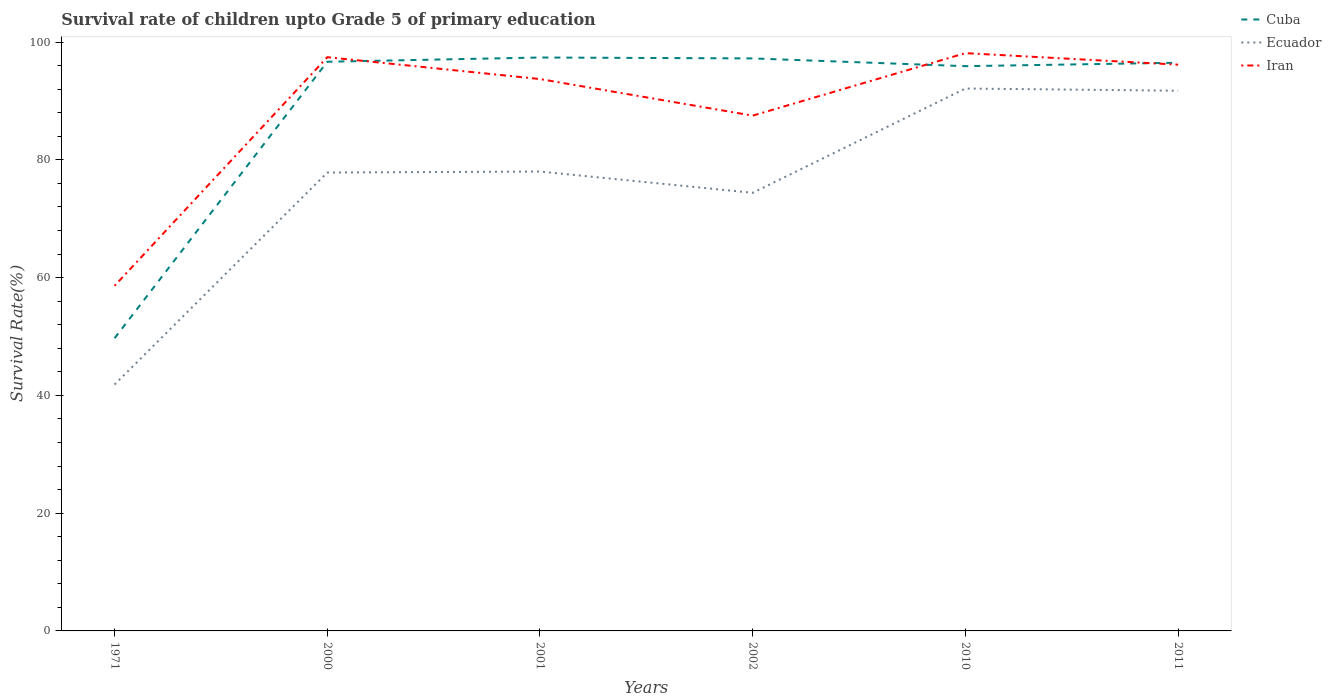How many different coloured lines are there?
Offer a terse response. 3. Across all years, what is the maximum survival rate of children in Iran?
Offer a very short reply. 58.61. What is the total survival rate of children in Ecuador in the graph?
Provide a succinct answer. -36. What is the difference between the highest and the second highest survival rate of children in Ecuador?
Make the answer very short. 50.27. Is the survival rate of children in Ecuador strictly greater than the survival rate of children in Iran over the years?
Offer a very short reply. Yes. How many lines are there?
Your answer should be very brief. 3. How many years are there in the graph?
Make the answer very short. 6. Are the values on the major ticks of Y-axis written in scientific E-notation?
Offer a very short reply. No. Does the graph contain any zero values?
Offer a very short reply. No. How many legend labels are there?
Provide a short and direct response. 3. What is the title of the graph?
Your answer should be compact. Survival rate of children upto Grade 5 of primary education. What is the label or title of the Y-axis?
Provide a succinct answer. Survival Rate(%). What is the Survival Rate(%) of Cuba in 1971?
Keep it short and to the point. 49.71. What is the Survival Rate(%) in Ecuador in 1971?
Make the answer very short. 41.85. What is the Survival Rate(%) in Iran in 1971?
Ensure brevity in your answer.  58.61. What is the Survival Rate(%) in Cuba in 2000?
Offer a terse response. 96.67. What is the Survival Rate(%) in Ecuador in 2000?
Give a very brief answer. 77.85. What is the Survival Rate(%) in Iran in 2000?
Ensure brevity in your answer.  97.44. What is the Survival Rate(%) in Cuba in 2001?
Ensure brevity in your answer.  97.39. What is the Survival Rate(%) of Ecuador in 2001?
Your response must be concise. 78.02. What is the Survival Rate(%) in Iran in 2001?
Provide a short and direct response. 93.73. What is the Survival Rate(%) of Cuba in 2002?
Offer a very short reply. 97.24. What is the Survival Rate(%) in Ecuador in 2002?
Provide a short and direct response. 74.41. What is the Survival Rate(%) in Iran in 2002?
Give a very brief answer. 87.52. What is the Survival Rate(%) of Cuba in 2010?
Your answer should be very brief. 95.92. What is the Survival Rate(%) of Ecuador in 2010?
Keep it short and to the point. 92.12. What is the Survival Rate(%) of Iran in 2010?
Your answer should be very brief. 98.13. What is the Survival Rate(%) of Cuba in 2011?
Keep it short and to the point. 96.5. What is the Survival Rate(%) in Ecuador in 2011?
Your answer should be compact. 91.75. What is the Survival Rate(%) of Iran in 2011?
Your answer should be compact. 96.18. Across all years, what is the maximum Survival Rate(%) of Cuba?
Your answer should be compact. 97.39. Across all years, what is the maximum Survival Rate(%) of Ecuador?
Make the answer very short. 92.12. Across all years, what is the maximum Survival Rate(%) in Iran?
Provide a succinct answer. 98.13. Across all years, what is the minimum Survival Rate(%) in Cuba?
Provide a succinct answer. 49.71. Across all years, what is the minimum Survival Rate(%) of Ecuador?
Your response must be concise. 41.85. Across all years, what is the minimum Survival Rate(%) of Iran?
Make the answer very short. 58.61. What is the total Survival Rate(%) in Cuba in the graph?
Offer a very short reply. 533.43. What is the total Survival Rate(%) of Ecuador in the graph?
Give a very brief answer. 456. What is the total Survival Rate(%) in Iran in the graph?
Offer a very short reply. 531.61. What is the difference between the Survival Rate(%) in Cuba in 1971 and that in 2000?
Provide a succinct answer. -46.96. What is the difference between the Survival Rate(%) of Ecuador in 1971 and that in 2000?
Your answer should be compact. -36. What is the difference between the Survival Rate(%) in Iran in 1971 and that in 2000?
Your answer should be compact. -38.83. What is the difference between the Survival Rate(%) of Cuba in 1971 and that in 2001?
Offer a very short reply. -47.68. What is the difference between the Survival Rate(%) of Ecuador in 1971 and that in 2001?
Make the answer very short. -36.17. What is the difference between the Survival Rate(%) of Iran in 1971 and that in 2001?
Offer a very short reply. -35.12. What is the difference between the Survival Rate(%) in Cuba in 1971 and that in 2002?
Provide a succinct answer. -47.52. What is the difference between the Survival Rate(%) in Ecuador in 1971 and that in 2002?
Ensure brevity in your answer.  -32.56. What is the difference between the Survival Rate(%) of Iran in 1971 and that in 2002?
Make the answer very short. -28.9. What is the difference between the Survival Rate(%) in Cuba in 1971 and that in 2010?
Ensure brevity in your answer.  -46.21. What is the difference between the Survival Rate(%) of Ecuador in 1971 and that in 2010?
Your response must be concise. -50.27. What is the difference between the Survival Rate(%) in Iran in 1971 and that in 2010?
Your response must be concise. -39.52. What is the difference between the Survival Rate(%) of Cuba in 1971 and that in 2011?
Make the answer very short. -46.79. What is the difference between the Survival Rate(%) of Ecuador in 1971 and that in 2011?
Ensure brevity in your answer.  -49.9. What is the difference between the Survival Rate(%) in Iran in 1971 and that in 2011?
Offer a very short reply. -37.56. What is the difference between the Survival Rate(%) of Cuba in 2000 and that in 2001?
Offer a very short reply. -0.72. What is the difference between the Survival Rate(%) in Ecuador in 2000 and that in 2001?
Give a very brief answer. -0.17. What is the difference between the Survival Rate(%) of Iran in 2000 and that in 2001?
Keep it short and to the point. 3.71. What is the difference between the Survival Rate(%) in Cuba in 2000 and that in 2002?
Offer a terse response. -0.57. What is the difference between the Survival Rate(%) of Ecuador in 2000 and that in 2002?
Your answer should be compact. 3.44. What is the difference between the Survival Rate(%) of Iran in 2000 and that in 2002?
Ensure brevity in your answer.  9.93. What is the difference between the Survival Rate(%) of Cuba in 2000 and that in 2010?
Make the answer very short. 0.75. What is the difference between the Survival Rate(%) in Ecuador in 2000 and that in 2010?
Keep it short and to the point. -14.27. What is the difference between the Survival Rate(%) of Iran in 2000 and that in 2010?
Ensure brevity in your answer.  -0.69. What is the difference between the Survival Rate(%) in Cuba in 2000 and that in 2011?
Your answer should be very brief. 0.17. What is the difference between the Survival Rate(%) of Ecuador in 2000 and that in 2011?
Provide a short and direct response. -13.9. What is the difference between the Survival Rate(%) in Iran in 2000 and that in 2011?
Offer a very short reply. 1.27. What is the difference between the Survival Rate(%) in Cuba in 2001 and that in 2002?
Keep it short and to the point. 0.15. What is the difference between the Survival Rate(%) in Ecuador in 2001 and that in 2002?
Your response must be concise. 3.61. What is the difference between the Survival Rate(%) in Iran in 2001 and that in 2002?
Offer a terse response. 6.21. What is the difference between the Survival Rate(%) in Cuba in 2001 and that in 2010?
Offer a very short reply. 1.47. What is the difference between the Survival Rate(%) in Ecuador in 2001 and that in 2010?
Your response must be concise. -14.1. What is the difference between the Survival Rate(%) in Iran in 2001 and that in 2010?
Offer a very short reply. -4.4. What is the difference between the Survival Rate(%) in Cuba in 2001 and that in 2011?
Offer a terse response. 0.89. What is the difference between the Survival Rate(%) in Ecuador in 2001 and that in 2011?
Offer a terse response. -13.73. What is the difference between the Survival Rate(%) in Iran in 2001 and that in 2011?
Your answer should be very brief. -2.45. What is the difference between the Survival Rate(%) of Cuba in 2002 and that in 2010?
Give a very brief answer. 1.32. What is the difference between the Survival Rate(%) in Ecuador in 2002 and that in 2010?
Your answer should be compact. -17.71. What is the difference between the Survival Rate(%) of Iran in 2002 and that in 2010?
Give a very brief answer. -10.61. What is the difference between the Survival Rate(%) of Cuba in 2002 and that in 2011?
Make the answer very short. 0.74. What is the difference between the Survival Rate(%) in Ecuador in 2002 and that in 2011?
Provide a short and direct response. -17.34. What is the difference between the Survival Rate(%) of Iran in 2002 and that in 2011?
Provide a short and direct response. -8.66. What is the difference between the Survival Rate(%) of Cuba in 2010 and that in 2011?
Your answer should be compact. -0.58. What is the difference between the Survival Rate(%) in Ecuador in 2010 and that in 2011?
Give a very brief answer. 0.37. What is the difference between the Survival Rate(%) in Iran in 2010 and that in 2011?
Keep it short and to the point. 1.95. What is the difference between the Survival Rate(%) of Cuba in 1971 and the Survival Rate(%) of Ecuador in 2000?
Your response must be concise. -28.14. What is the difference between the Survival Rate(%) of Cuba in 1971 and the Survival Rate(%) of Iran in 2000?
Provide a short and direct response. -47.73. What is the difference between the Survival Rate(%) of Ecuador in 1971 and the Survival Rate(%) of Iran in 2000?
Provide a succinct answer. -55.6. What is the difference between the Survival Rate(%) of Cuba in 1971 and the Survival Rate(%) of Ecuador in 2001?
Offer a terse response. -28.31. What is the difference between the Survival Rate(%) in Cuba in 1971 and the Survival Rate(%) in Iran in 2001?
Keep it short and to the point. -44.02. What is the difference between the Survival Rate(%) of Ecuador in 1971 and the Survival Rate(%) of Iran in 2001?
Your answer should be compact. -51.88. What is the difference between the Survival Rate(%) in Cuba in 1971 and the Survival Rate(%) in Ecuador in 2002?
Provide a succinct answer. -24.7. What is the difference between the Survival Rate(%) in Cuba in 1971 and the Survival Rate(%) in Iran in 2002?
Keep it short and to the point. -37.8. What is the difference between the Survival Rate(%) in Ecuador in 1971 and the Survival Rate(%) in Iran in 2002?
Offer a very short reply. -45.67. What is the difference between the Survival Rate(%) in Cuba in 1971 and the Survival Rate(%) in Ecuador in 2010?
Your answer should be compact. -42.41. What is the difference between the Survival Rate(%) in Cuba in 1971 and the Survival Rate(%) in Iran in 2010?
Make the answer very short. -48.42. What is the difference between the Survival Rate(%) of Ecuador in 1971 and the Survival Rate(%) of Iran in 2010?
Offer a terse response. -56.28. What is the difference between the Survival Rate(%) in Cuba in 1971 and the Survival Rate(%) in Ecuador in 2011?
Offer a very short reply. -42.04. What is the difference between the Survival Rate(%) in Cuba in 1971 and the Survival Rate(%) in Iran in 2011?
Keep it short and to the point. -46.46. What is the difference between the Survival Rate(%) in Ecuador in 1971 and the Survival Rate(%) in Iran in 2011?
Provide a succinct answer. -54.33. What is the difference between the Survival Rate(%) of Cuba in 2000 and the Survival Rate(%) of Ecuador in 2001?
Provide a short and direct response. 18.65. What is the difference between the Survival Rate(%) of Cuba in 2000 and the Survival Rate(%) of Iran in 2001?
Ensure brevity in your answer.  2.94. What is the difference between the Survival Rate(%) of Ecuador in 2000 and the Survival Rate(%) of Iran in 2001?
Give a very brief answer. -15.88. What is the difference between the Survival Rate(%) of Cuba in 2000 and the Survival Rate(%) of Ecuador in 2002?
Offer a very short reply. 22.26. What is the difference between the Survival Rate(%) in Cuba in 2000 and the Survival Rate(%) in Iran in 2002?
Offer a terse response. 9.15. What is the difference between the Survival Rate(%) of Ecuador in 2000 and the Survival Rate(%) of Iran in 2002?
Your answer should be compact. -9.67. What is the difference between the Survival Rate(%) of Cuba in 2000 and the Survival Rate(%) of Ecuador in 2010?
Give a very brief answer. 4.55. What is the difference between the Survival Rate(%) in Cuba in 2000 and the Survival Rate(%) in Iran in 2010?
Your response must be concise. -1.46. What is the difference between the Survival Rate(%) in Ecuador in 2000 and the Survival Rate(%) in Iran in 2010?
Your answer should be very brief. -20.28. What is the difference between the Survival Rate(%) in Cuba in 2000 and the Survival Rate(%) in Ecuador in 2011?
Give a very brief answer. 4.92. What is the difference between the Survival Rate(%) of Cuba in 2000 and the Survival Rate(%) of Iran in 2011?
Offer a very short reply. 0.49. What is the difference between the Survival Rate(%) in Ecuador in 2000 and the Survival Rate(%) in Iran in 2011?
Your answer should be very brief. -18.33. What is the difference between the Survival Rate(%) in Cuba in 2001 and the Survival Rate(%) in Ecuador in 2002?
Your answer should be very brief. 22.98. What is the difference between the Survival Rate(%) of Cuba in 2001 and the Survival Rate(%) of Iran in 2002?
Your answer should be compact. 9.87. What is the difference between the Survival Rate(%) in Ecuador in 2001 and the Survival Rate(%) in Iran in 2002?
Offer a terse response. -9.49. What is the difference between the Survival Rate(%) in Cuba in 2001 and the Survival Rate(%) in Ecuador in 2010?
Ensure brevity in your answer.  5.27. What is the difference between the Survival Rate(%) in Cuba in 2001 and the Survival Rate(%) in Iran in 2010?
Your response must be concise. -0.74. What is the difference between the Survival Rate(%) in Ecuador in 2001 and the Survival Rate(%) in Iran in 2010?
Keep it short and to the point. -20.11. What is the difference between the Survival Rate(%) of Cuba in 2001 and the Survival Rate(%) of Ecuador in 2011?
Offer a terse response. 5.64. What is the difference between the Survival Rate(%) in Cuba in 2001 and the Survival Rate(%) in Iran in 2011?
Your answer should be compact. 1.21. What is the difference between the Survival Rate(%) of Ecuador in 2001 and the Survival Rate(%) of Iran in 2011?
Ensure brevity in your answer.  -18.15. What is the difference between the Survival Rate(%) of Cuba in 2002 and the Survival Rate(%) of Ecuador in 2010?
Keep it short and to the point. 5.11. What is the difference between the Survival Rate(%) in Cuba in 2002 and the Survival Rate(%) in Iran in 2010?
Ensure brevity in your answer.  -0.9. What is the difference between the Survival Rate(%) of Ecuador in 2002 and the Survival Rate(%) of Iran in 2010?
Offer a terse response. -23.72. What is the difference between the Survival Rate(%) of Cuba in 2002 and the Survival Rate(%) of Ecuador in 2011?
Provide a short and direct response. 5.49. What is the difference between the Survival Rate(%) of Cuba in 2002 and the Survival Rate(%) of Iran in 2011?
Your answer should be very brief. 1.06. What is the difference between the Survival Rate(%) in Ecuador in 2002 and the Survival Rate(%) in Iran in 2011?
Make the answer very short. -21.77. What is the difference between the Survival Rate(%) of Cuba in 2010 and the Survival Rate(%) of Ecuador in 2011?
Make the answer very short. 4.17. What is the difference between the Survival Rate(%) in Cuba in 2010 and the Survival Rate(%) in Iran in 2011?
Ensure brevity in your answer.  -0.26. What is the difference between the Survival Rate(%) of Ecuador in 2010 and the Survival Rate(%) of Iran in 2011?
Your response must be concise. -4.05. What is the average Survival Rate(%) in Cuba per year?
Give a very brief answer. 88.9. What is the average Survival Rate(%) of Ecuador per year?
Your answer should be very brief. 76. What is the average Survival Rate(%) of Iran per year?
Keep it short and to the point. 88.6. In the year 1971, what is the difference between the Survival Rate(%) in Cuba and Survival Rate(%) in Ecuador?
Offer a terse response. 7.86. In the year 1971, what is the difference between the Survival Rate(%) in Cuba and Survival Rate(%) in Iran?
Ensure brevity in your answer.  -8.9. In the year 1971, what is the difference between the Survival Rate(%) in Ecuador and Survival Rate(%) in Iran?
Offer a very short reply. -16.76. In the year 2000, what is the difference between the Survival Rate(%) of Cuba and Survival Rate(%) of Ecuador?
Your answer should be compact. 18.82. In the year 2000, what is the difference between the Survival Rate(%) in Cuba and Survival Rate(%) in Iran?
Your answer should be very brief. -0.77. In the year 2000, what is the difference between the Survival Rate(%) of Ecuador and Survival Rate(%) of Iran?
Your response must be concise. -19.59. In the year 2001, what is the difference between the Survival Rate(%) in Cuba and Survival Rate(%) in Ecuador?
Keep it short and to the point. 19.37. In the year 2001, what is the difference between the Survival Rate(%) in Cuba and Survival Rate(%) in Iran?
Offer a very short reply. 3.66. In the year 2001, what is the difference between the Survival Rate(%) of Ecuador and Survival Rate(%) of Iran?
Offer a terse response. -15.71. In the year 2002, what is the difference between the Survival Rate(%) of Cuba and Survival Rate(%) of Ecuador?
Provide a succinct answer. 22.83. In the year 2002, what is the difference between the Survival Rate(%) in Cuba and Survival Rate(%) in Iran?
Provide a short and direct response. 9.72. In the year 2002, what is the difference between the Survival Rate(%) in Ecuador and Survival Rate(%) in Iran?
Offer a very short reply. -13.11. In the year 2010, what is the difference between the Survival Rate(%) in Cuba and Survival Rate(%) in Ecuador?
Make the answer very short. 3.8. In the year 2010, what is the difference between the Survival Rate(%) of Cuba and Survival Rate(%) of Iran?
Provide a short and direct response. -2.21. In the year 2010, what is the difference between the Survival Rate(%) of Ecuador and Survival Rate(%) of Iran?
Give a very brief answer. -6.01. In the year 2011, what is the difference between the Survival Rate(%) of Cuba and Survival Rate(%) of Ecuador?
Provide a short and direct response. 4.75. In the year 2011, what is the difference between the Survival Rate(%) in Cuba and Survival Rate(%) in Iran?
Give a very brief answer. 0.32. In the year 2011, what is the difference between the Survival Rate(%) in Ecuador and Survival Rate(%) in Iran?
Provide a short and direct response. -4.43. What is the ratio of the Survival Rate(%) of Cuba in 1971 to that in 2000?
Your response must be concise. 0.51. What is the ratio of the Survival Rate(%) of Ecuador in 1971 to that in 2000?
Ensure brevity in your answer.  0.54. What is the ratio of the Survival Rate(%) of Iran in 1971 to that in 2000?
Offer a very short reply. 0.6. What is the ratio of the Survival Rate(%) in Cuba in 1971 to that in 2001?
Provide a succinct answer. 0.51. What is the ratio of the Survival Rate(%) in Ecuador in 1971 to that in 2001?
Offer a very short reply. 0.54. What is the ratio of the Survival Rate(%) in Iran in 1971 to that in 2001?
Provide a succinct answer. 0.63. What is the ratio of the Survival Rate(%) of Cuba in 1971 to that in 2002?
Provide a short and direct response. 0.51. What is the ratio of the Survival Rate(%) of Ecuador in 1971 to that in 2002?
Keep it short and to the point. 0.56. What is the ratio of the Survival Rate(%) of Iran in 1971 to that in 2002?
Ensure brevity in your answer.  0.67. What is the ratio of the Survival Rate(%) in Cuba in 1971 to that in 2010?
Your response must be concise. 0.52. What is the ratio of the Survival Rate(%) of Ecuador in 1971 to that in 2010?
Make the answer very short. 0.45. What is the ratio of the Survival Rate(%) in Iran in 1971 to that in 2010?
Make the answer very short. 0.6. What is the ratio of the Survival Rate(%) of Cuba in 1971 to that in 2011?
Keep it short and to the point. 0.52. What is the ratio of the Survival Rate(%) of Ecuador in 1971 to that in 2011?
Your response must be concise. 0.46. What is the ratio of the Survival Rate(%) of Iran in 1971 to that in 2011?
Offer a very short reply. 0.61. What is the ratio of the Survival Rate(%) in Cuba in 2000 to that in 2001?
Your answer should be compact. 0.99. What is the ratio of the Survival Rate(%) of Ecuador in 2000 to that in 2001?
Offer a very short reply. 1. What is the ratio of the Survival Rate(%) of Iran in 2000 to that in 2001?
Keep it short and to the point. 1.04. What is the ratio of the Survival Rate(%) in Cuba in 2000 to that in 2002?
Provide a short and direct response. 0.99. What is the ratio of the Survival Rate(%) of Ecuador in 2000 to that in 2002?
Give a very brief answer. 1.05. What is the ratio of the Survival Rate(%) in Iran in 2000 to that in 2002?
Your answer should be very brief. 1.11. What is the ratio of the Survival Rate(%) in Ecuador in 2000 to that in 2010?
Offer a very short reply. 0.85. What is the ratio of the Survival Rate(%) of Iran in 2000 to that in 2010?
Provide a succinct answer. 0.99. What is the ratio of the Survival Rate(%) of Ecuador in 2000 to that in 2011?
Provide a short and direct response. 0.85. What is the ratio of the Survival Rate(%) of Iran in 2000 to that in 2011?
Give a very brief answer. 1.01. What is the ratio of the Survival Rate(%) of Ecuador in 2001 to that in 2002?
Your response must be concise. 1.05. What is the ratio of the Survival Rate(%) of Iran in 2001 to that in 2002?
Make the answer very short. 1.07. What is the ratio of the Survival Rate(%) in Cuba in 2001 to that in 2010?
Provide a short and direct response. 1.02. What is the ratio of the Survival Rate(%) in Ecuador in 2001 to that in 2010?
Keep it short and to the point. 0.85. What is the ratio of the Survival Rate(%) in Iran in 2001 to that in 2010?
Ensure brevity in your answer.  0.96. What is the ratio of the Survival Rate(%) of Cuba in 2001 to that in 2011?
Offer a very short reply. 1.01. What is the ratio of the Survival Rate(%) of Ecuador in 2001 to that in 2011?
Provide a short and direct response. 0.85. What is the ratio of the Survival Rate(%) of Iran in 2001 to that in 2011?
Offer a terse response. 0.97. What is the ratio of the Survival Rate(%) of Cuba in 2002 to that in 2010?
Offer a terse response. 1.01. What is the ratio of the Survival Rate(%) in Ecuador in 2002 to that in 2010?
Your answer should be compact. 0.81. What is the ratio of the Survival Rate(%) of Iran in 2002 to that in 2010?
Your answer should be very brief. 0.89. What is the ratio of the Survival Rate(%) of Cuba in 2002 to that in 2011?
Make the answer very short. 1.01. What is the ratio of the Survival Rate(%) in Ecuador in 2002 to that in 2011?
Your response must be concise. 0.81. What is the ratio of the Survival Rate(%) of Iran in 2002 to that in 2011?
Ensure brevity in your answer.  0.91. What is the ratio of the Survival Rate(%) of Ecuador in 2010 to that in 2011?
Provide a short and direct response. 1. What is the ratio of the Survival Rate(%) of Iran in 2010 to that in 2011?
Provide a short and direct response. 1.02. What is the difference between the highest and the second highest Survival Rate(%) in Cuba?
Offer a terse response. 0.15. What is the difference between the highest and the second highest Survival Rate(%) in Ecuador?
Offer a terse response. 0.37. What is the difference between the highest and the second highest Survival Rate(%) in Iran?
Keep it short and to the point. 0.69. What is the difference between the highest and the lowest Survival Rate(%) of Cuba?
Provide a short and direct response. 47.68. What is the difference between the highest and the lowest Survival Rate(%) of Ecuador?
Your response must be concise. 50.27. What is the difference between the highest and the lowest Survival Rate(%) in Iran?
Offer a terse response. 39.52. 